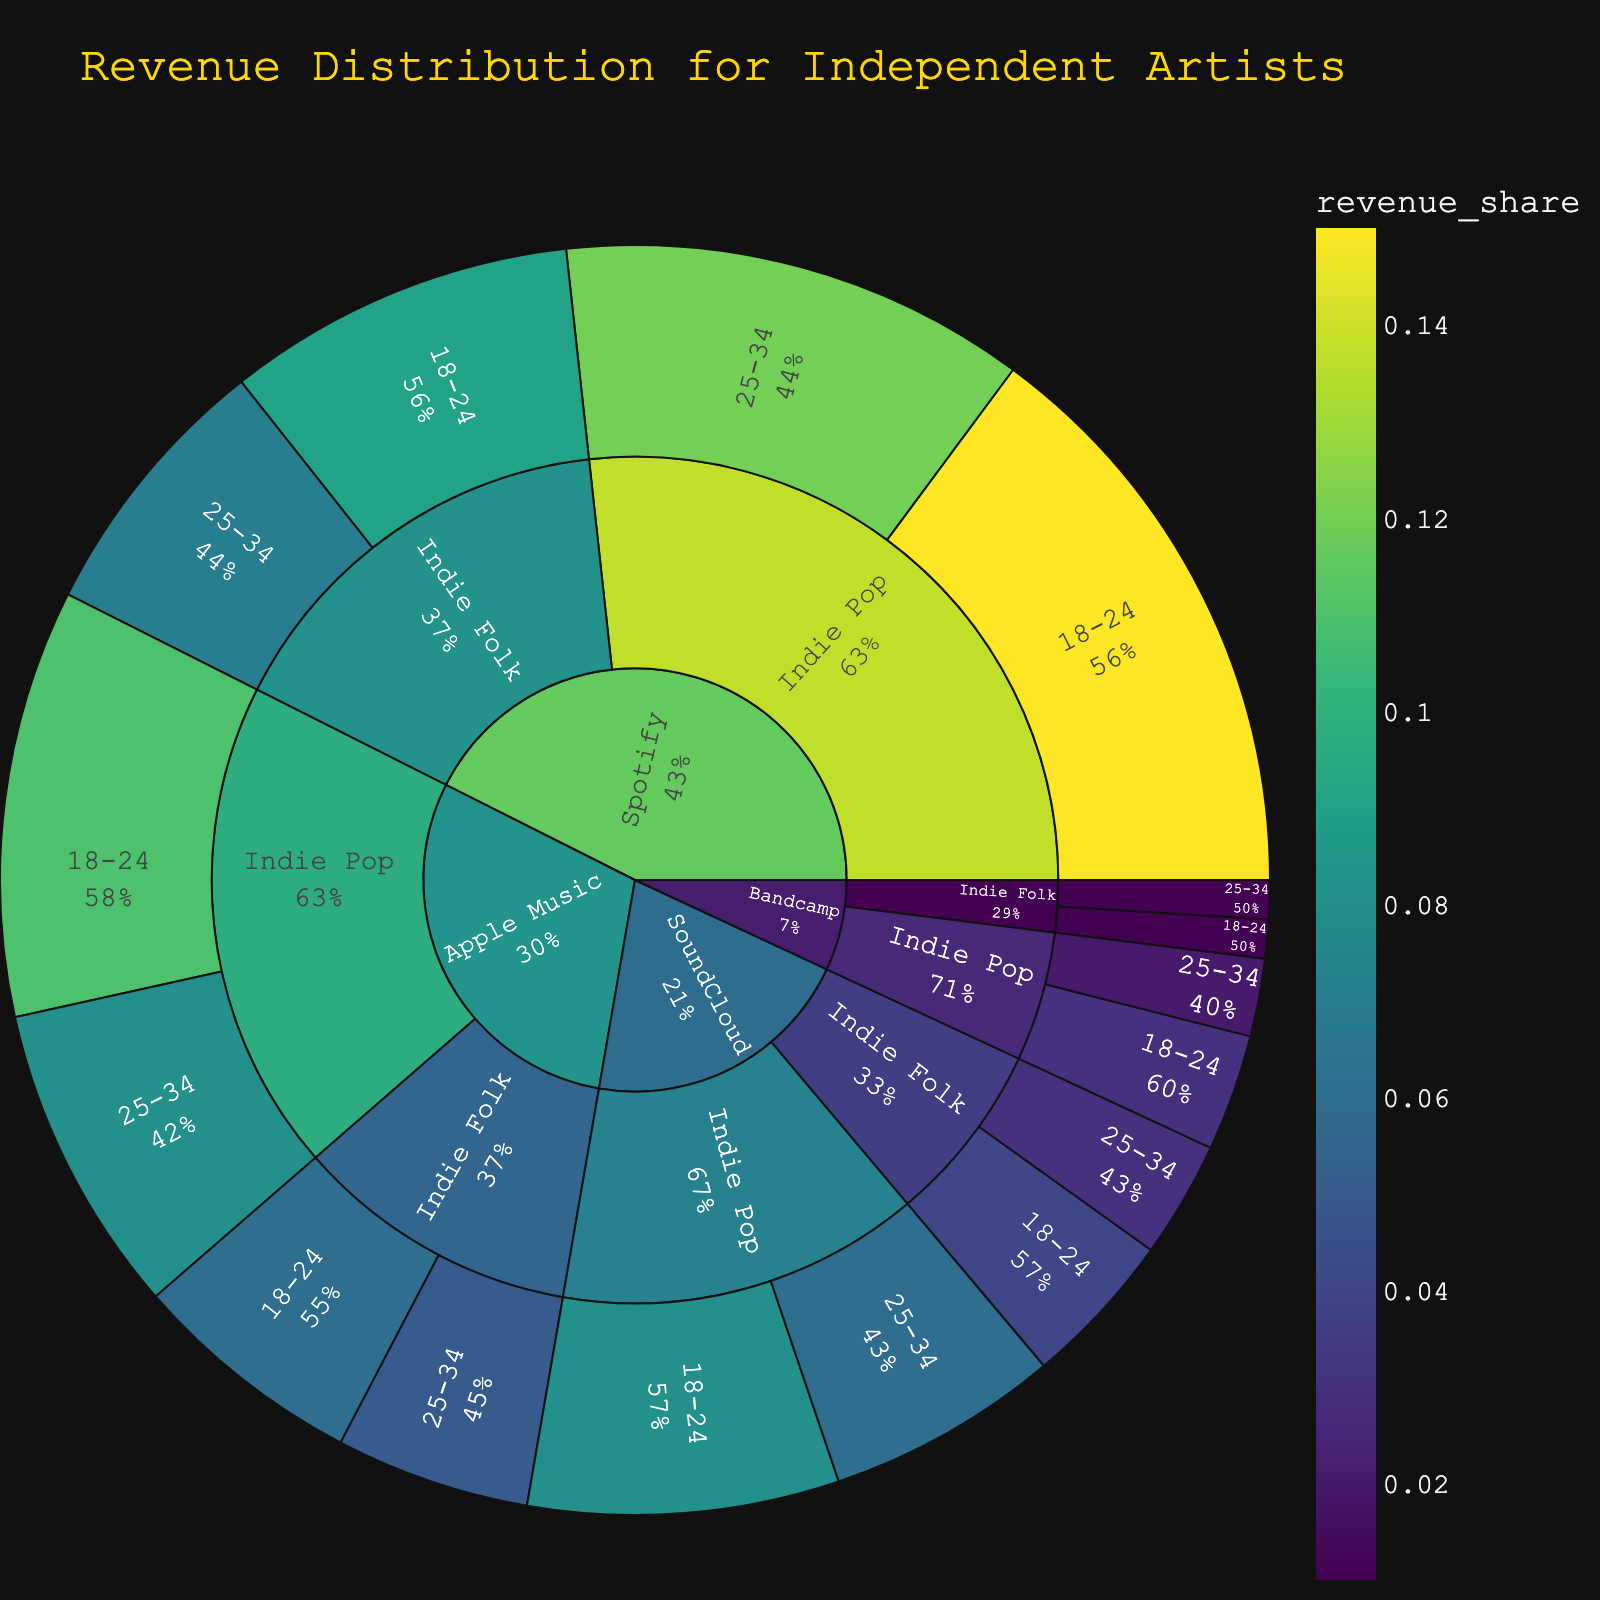Which streaming platform shows the highest revenue share for Indie Pop among the 18-24 age group? Looking at the outermost layer of the sunburst plot for the Indie Pop section and focusing on the 18-24 age group, the color intensity indicates the revenue share. In this case, Spotify has the highest revenue share.
Answer: Spotify What is the total revenue share for Apple Music across all music styles and age groups? To find the total revenue share for Apple Music, sum the revenue shares of all listed categories under Apple Music: (0.11 + 0.08 + 0.06 + 0.05). The total revenue share is 0.30.
Answer: 0.30 Between Spotify and Bandcamp, which platform has a higher revenue share for Indie Folk among the 25-34 age group? Focus on the part of the sunburst plot where Indie Folk and 25-34 age group intersect for both Spotify and Bandcamp. Spotify's share is 0.07, and Bandcamp's share is 0.01. Therefore, Spotify has a higher revenue share.
Answer: Spotify What percentage of the total revenue share does Indie Pop contribute on Spotify? The total revenue share for Spotify is (0.15 + 0.12 + 0.09 + 0.07) = 0.43. Indie Pop's revenue share on Spotify is (0.15 + 0.12) = 0.27. The percentage is (0.27 / 0.43) * 100% ≈ 62.79%.
Answer: 62.79% Which listener age group generates the most revenue for SoundCloud's Indie Folk? Look at the outermost layers of SoundCloud's Indie Folk section. Compare the revenue shares for the 18-24 (0.04) and 25-34 (0.03) age groups. The 18-24 age group generates more revenue.
Answer: 18-24 Compare the total revenue shares of Indie Folk between Spotify and SoundCloud. Sum the revenue shares of Indie Folk for both Spotify (0.09 + 0.07 = 0.16) and SoundCloud (0.04 + 0.03 = 0.07). Spotify's total is 0.16, and SoundCloud's total is 0.07. So Spotify has a higher total revenue share.
Answer: Spotify Which music style has a greater revenue share for the 18-24 age group on Bandcamp? Look at the Bandcamp segment and compare the outermost layer's revenue shares for the 18-24 age group. For Indie Pop, it's 0.03, and for Indie Folk, it's 0.01. Indie Pop has a greater revenue share.
Answer: Indie Pop What is the combined revenue share of Indie Folk for all platforms in the 25-34 age group? Add the revenue shares for Indie Folk and 25-34 age group across all platforms: (0.07 + 0.05 + 0.03 + 0.01). The combined revenue share is 0.16.
Answer: 0.16 What is the overall revenue share of Indie Pop across all platforms and age groups? Sum the revenue shares for Indie Pop for all platforms and age groups: (0.15 + 0.12 + 0.11 + 0.08 + 0.08 + 0.06 + 0.03 + 0.02). The total revenue share is 0.65.
Answer: 0.65 